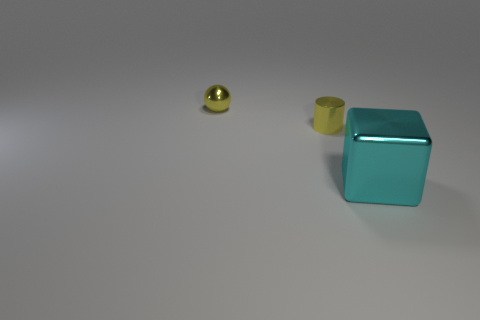Add 2 big blue cylinders. How many objects exist? 5 Subtract all cylinders. How many objects are left? 2 Subtract all green blocks. How many cyan cylinders are left? 0 Subtract all small things. Subtract all brown objects. How many objects are left? 1 Add 3 yellow shiny cylinders. How many yellow shiny cylinders are left? 4 Add 2 small yellow shiny cylinders. How many small yellow shiny cylinders exist? 3 Subtract 0 yellow cubes. How many objects are left? 3 Subtract all gray cylinders. Subtract all gray spheres. How many cylinders are left? 1 